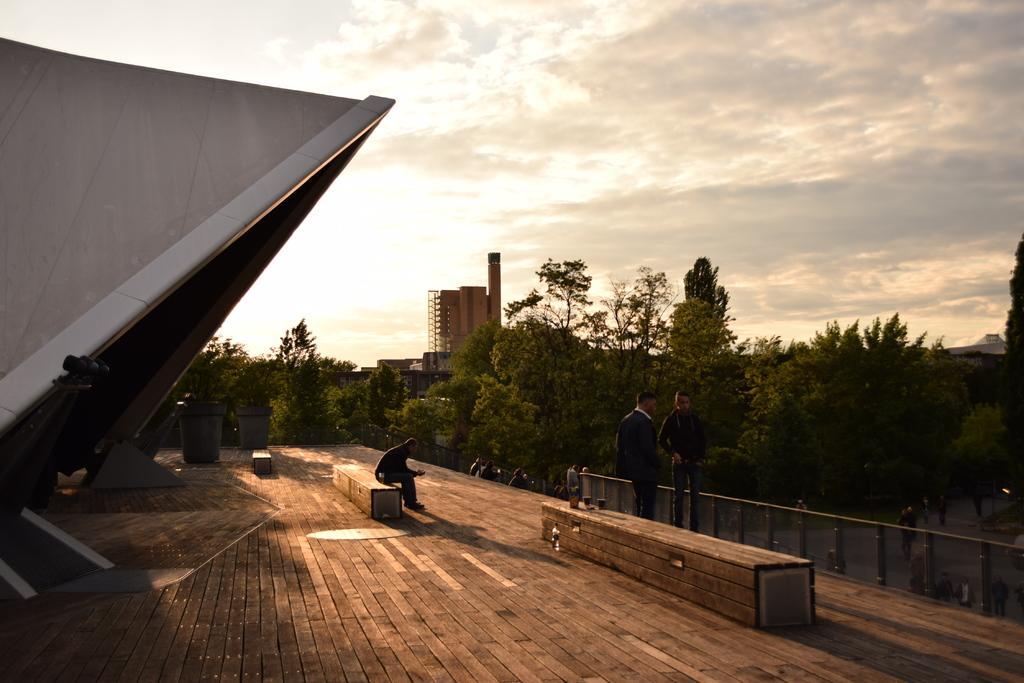How would you summarize this image in a sentence or two? In this image, we can see people and one of them is sitting on the bench. In the background, we can see a shed and some benches and there are large pots and trees and buildings and there is a railing. At the bottom, there is wood and at the top, there is sky. 